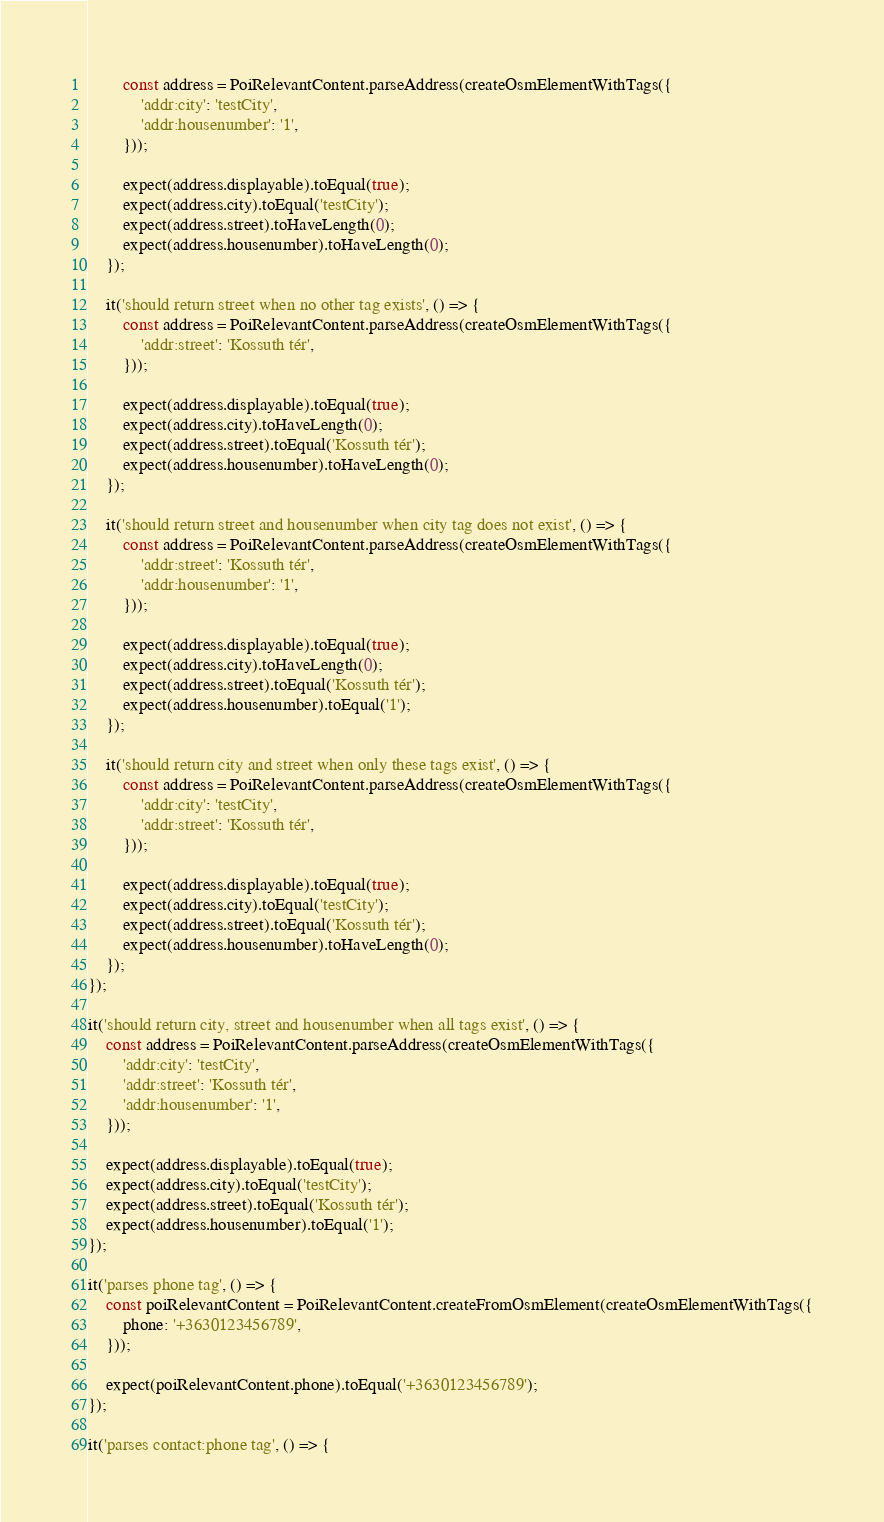Convert code to text. <code><loc_0><loc_0><loc_500><loc_500><_JavaScript_>		const address = PoiRelevantContent.parseAddress(createOsmElementWithTags({
			'addr:city': 'testCity',
			'addr:housenumber': '1',
		}));

		expect(address.displayable).toEqual(true);
		expect(address.city).toEqual('testCity');
		expect(address.street).toHaveLength(0);
		expect(address.housenumber).toHaveLength(0);
	});

	it('should return street when no other tag exists', () => {
		const address = PoiRelevantContent.parseAddress(createOsmElementWithTags({
			'addr:street': 'Kossuth tér',
		}));

		expect(address.displayable).toEqual(true);
		expect(address.city).toHaveLength(0);
		expect(address.street).toEqual('Kossuth tér');
		expect(address.housenumber).toHaveLength(0);
	});

	it('should return street and housenumber when city tag does not exist', () => {
		const address = PoiRelevantContent.parseAddress(createOsmElementWithTags({
			'addr:street': 'Kossuth tér',
			'addr:housenumber': '1',
		}));

		expect(address.displayable).toEqual(true);
		expect(address.city).toHaveLength(0);
		expect(address.street).toEqual('Kossuth tér');
		expect(address.housenumber).toEqual('1');
	});

	it('should return city and street when only these tags exist', () => {
		const address = PoiRelevantContent.parseAddress(createOsmElementWithTags({
			'addr:city': 'testCity',
			'addr:street': 'Kossuth tér',
		}));

		expect(address.displayable).toEqual(true);
		expect(address.city).toEqual('testCity');
		expect(address.street).toEqual('Kossuth tér');
		expect(address.housenumber).toHaveLength(0);
	});
});

it('should return city, street and housenumber when all tags exist', () => {
	const address = PoiRelevantContent.parseAddress(createOsmElementWithTags({
		'addr:city': 'testCity',
		'addr:street': 'Kossuth tér',
		'addr:housenumber': '1',
	}));

	expect(address.displayable).toEqual(true);
	expect(address.city).toEqual('testCity');
	expect(address.street).toEqual('Kossuth tér');
	expect(address.housenumber).toEqual('1');
});

it('parses phone tag', () => {
	const poiRelevantContent = PoiRelevantContent.createFromOsmElement(createOsmElementWithTags({
		phone: '+3630123456789',
	}));

	expect(poiRelevantContent.phone).toEqual('+3630123456789');
});

it('parses contact:phone tag', () => {</code> 